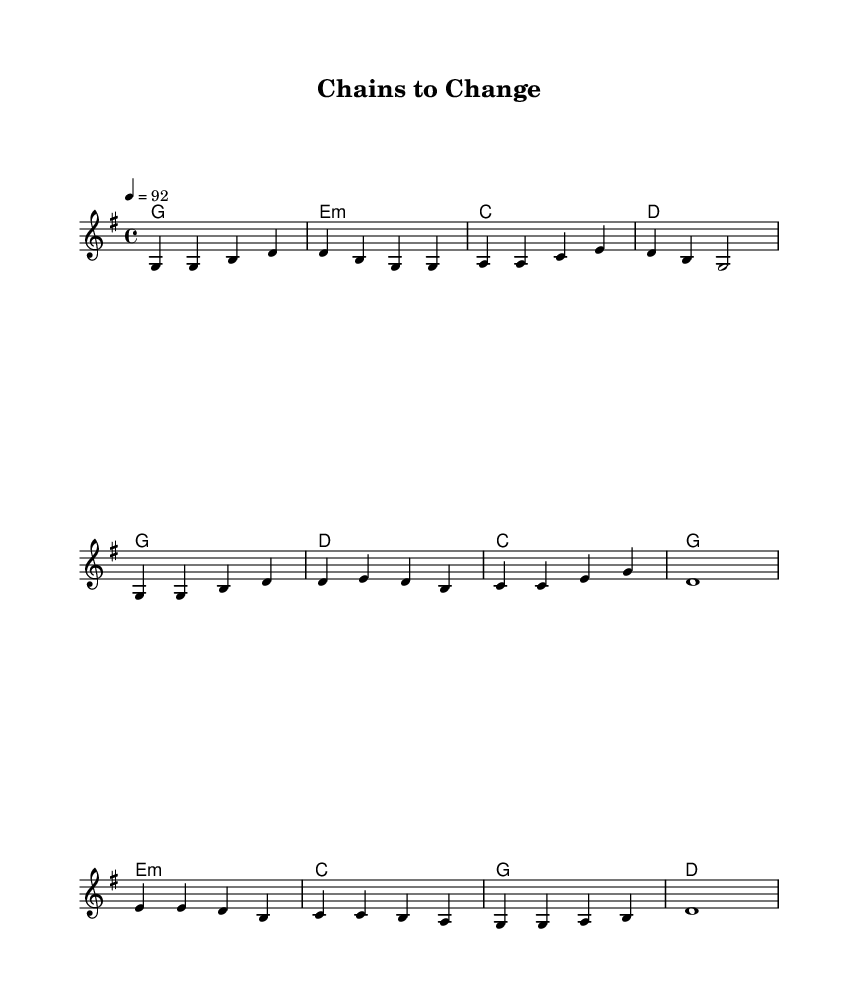What is the key signature of this music? The key signature is G major, which has one sharp (F#).
Answer: G major What is the time signature of this music? The time signature is 4/4, meaning there are four beats in each measure and a quarter note gets one beat.
Answer: 4/4 What is the tempo marking of this piece? The tempo marking indicates a speed of 92 beats per minute, suggesting a moderate pace for the performance.
Answer: 92 How many bars are in the verse section? There are four bars in the verse section as indicated by the separate phrases before the chorus begins.
Answer: Four Which chord is used in the bridge section? The chords used in the bridge section include Em, C, G, and D, showcasing a typical progression often found in country music.
Answer: Em What is the main theme conveyed in the lyrics? The lyrics reflect overcoming challenges and personal transformation, which is a common theme in modern country anthems about resilience.
Answer: Overcoming adversity What is the title of this piece? The title of the piece is "Chains to Change," which aligns with the theme of transformation and overcoming obstacles reflected in the lyrics.
Answer: Chains to Change 